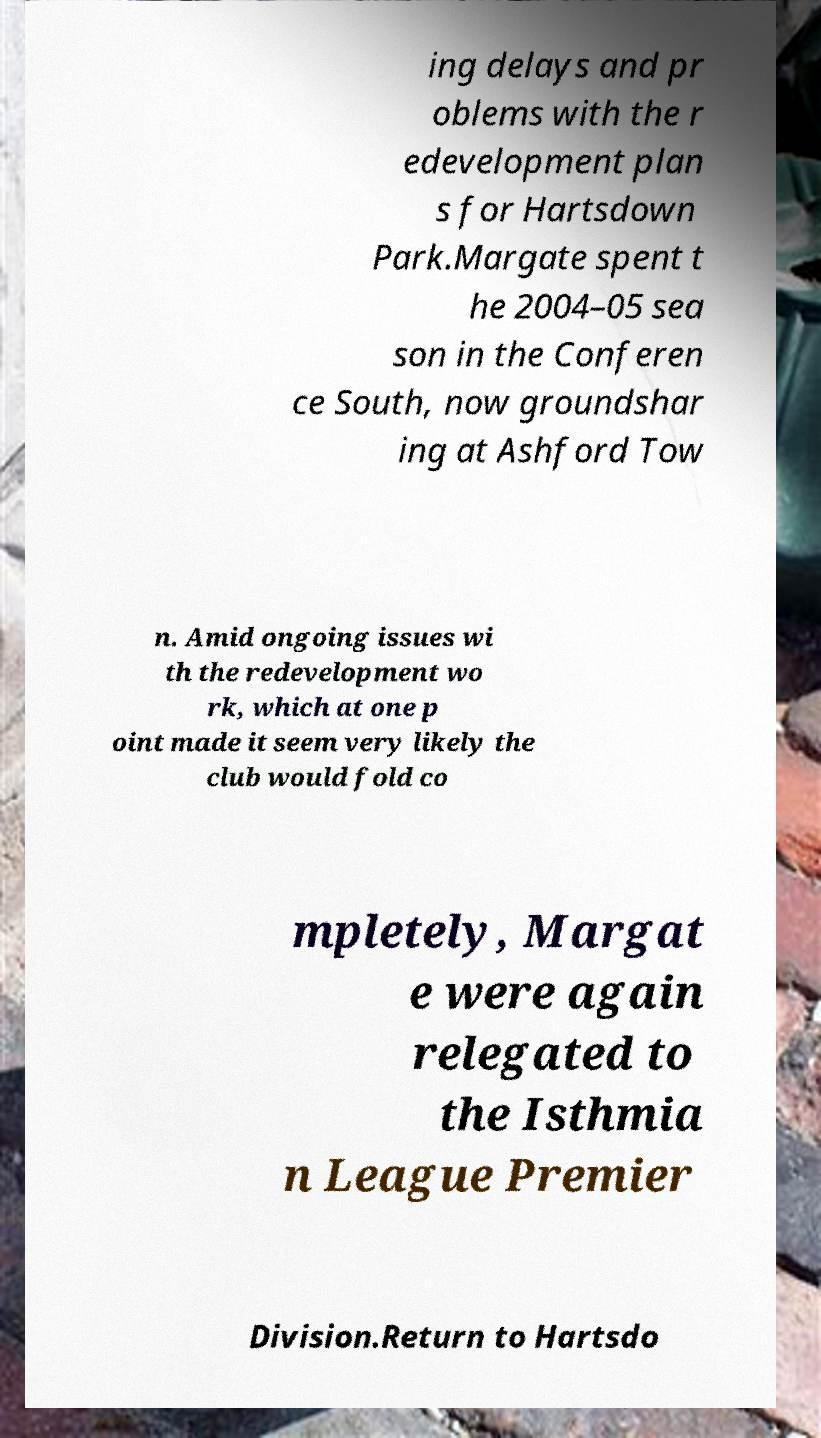Could you assist in decoding the text presented in this image and type it out clearly? ing delays and pr oblems with the r edevelopment plan s for Hartsdown Park.Margate spent t he 2004–05 sea son in the Conferen ce South, now groundshar ing at Ashford Tow n. Amid ongoing issues wi th the redevelopment wo rk, which at one p oint made it seem very likely the club would fold co mpletely, Margat e were again relegated to the Isthmia n League Premier Division.Return to Hartsdo 